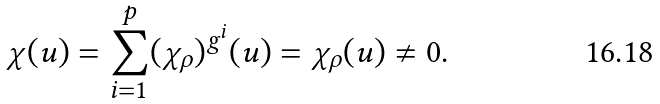Convert formula to latex. <formula><loc_0><loc_0><loc_500><loc_500>\chi ( u ) = \sum _ { i = 1 } ^ { p } ( \chi _ { \rho } ) ^ { g ^ { i } } ( u ) = \chi _ { \rho } ( u ) \neq 0 .</formula> 